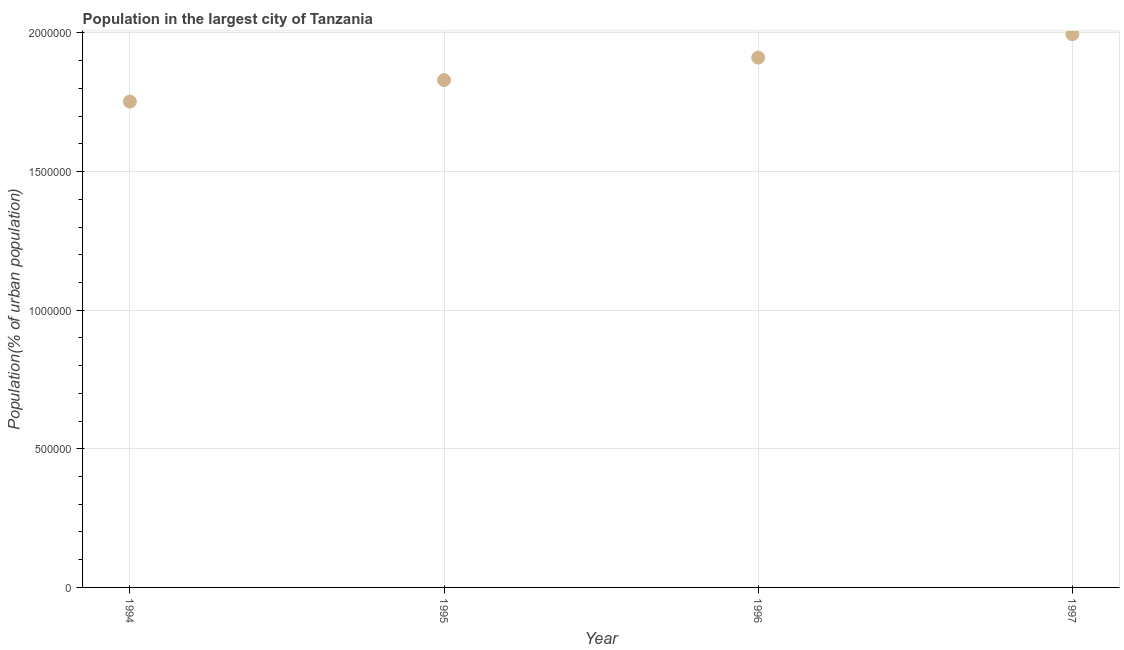What is the population in largest city in 1997?
Offer a terse response. 2.00e+06. Across all years, what is the maximum population in largest city?
Your response must be concise. 2.00e+06. Across all years, what is the minimum population in largest city?
Your answer should be compact. 1.75e+06. In which year was the population in largest city minimum?
Provide a short and direct response. 1994. What is the sum of the population in largest city?
Ensure brevity in your answer.  7.49e+06. What is the difference between the population in largest city in 1995 and 1997?
Ensure brevity in your answer.  -1.66e+05. What is the average population in largest city per year?
Your answer should be very brief. 1.87e+06. What is the median population in largest city?
Provide a succinct answer. 1.87e+06. In how many years, is the population in largest city greater than 1500000 %?
Your answer should be compact. 4. What is the ratio of the population in largest city in 1995 to that in 1996?
Provide a succinct answer. 0.96. Is the population in largest city in 1995 less than that in 1997?
Ensure brevity in your answer.  Yes. Is the difference between the population in largest city in 1995 and 1997 greater than the difference between any two years?
Your answer should be compact. No. What is the difference between the highest and the second highest population in largest city?
Your response must be concise. 8.44e+04. What is the difference between the highest and the lowest population in largest city?
Ensure brevity in your answer.  2.43e+05. In how many years, is the population in largest city greater than the average population in largest city taken over all years?
Provide a succinct answer. 2. How many years are there in the graph?
Provide a succinct answer. 4. What is the title of the graph?
Keep it short and to the point. Population in the largest city of Tanzania. What is the label or title of the X-axis?
Provide a succinct answer. Year. What is the label or title of the Y-axis?
Your answer should be very brief. Population(% of urban population). What is the Population(% of urban population) in 1994?
Keep it short and to the point. 1.75e+06. What is the Population(% of urban population) in 1995?
Keep it short and to the point. 1.83e+06. What is the Population(% of urban population) in 1996?
Give a very brief answer. 1.91e+06. What is the Population(% of urban population) in 1997?
Provide a short and direct response. 2.00e+06. What is the difference between the Population(% of urban population) in 1994 and 1995?
Your answer should be very brief. -7.75e+04. What is the difference between the Population(% of urban population) in 1994 and 1996?
Your response must be concise. -1.59e+05. What is the difference between the Population(% of urban population) in 1994 and 1997?
Your answer should be compact. -2.43e+05. What is the difference between the Population(% of urban population) in 1995 and 1996?
Your answer should be compact. -8.11e+04. What is the difference between the Population(% of urban population) in 1995 and 1997?
Offer a terse response. -1.66e+05. What is the difference between the Population(% of urban population) in 1996 and 1997?
Your answer should be very brief. -8.44e+04. What is the ratio of the Population(% of urban population) in 1994 to that in 1995?
Your response must be concise. 0.96. What is the ratio of the Population(% of urban population) in 1994 to that in 1996?
Make the answer very short. 0.92. What is the ratio of the Population(% of urban population) in 1994 to that in 1997?
Provide a short and direct response. 0.88. What is the ratio of the Population(% of urban population) in 1995 to that in 1996?
Give a very brief answer. 0.96. What is the ratio of the Population(% of urban population) in 1995 to that in 1997?
Your answer should be compact. 0.92. What is the ratio of the Population(% of urban population) in 1996 to that in 1997?
Offer a very short reply. 0.96. 